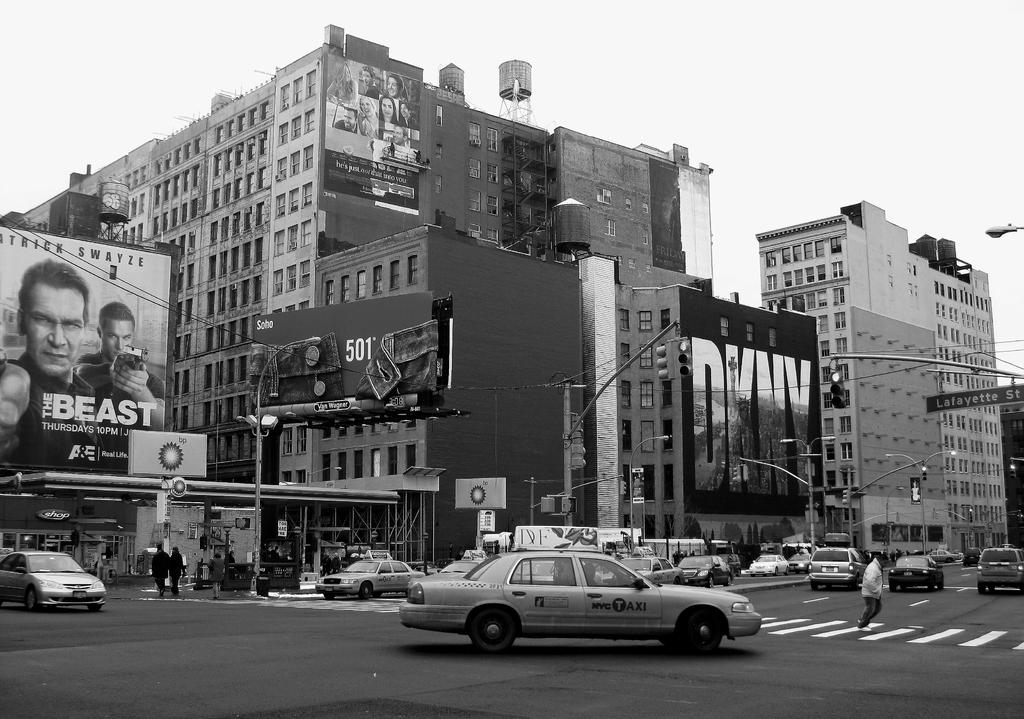What movie is in the poster ad?
Provide a short and direct response. The beast. Is there a taxi with the word taxi on it in this picture?
Ensure brevity in your answer.  Yes. 